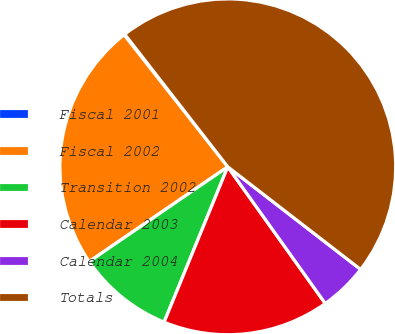Convert chart to OTSL. <chart><loc_0><loc_0><loc_500><loc_500><pie_chart><fcel>Fiscal 2001<fcel>Fiscal 2002<fcel>Transition 2002<fcel>Calendar 2003<fcel>Calendar 2004<fcel>Totals<nl><fcel>0.08%<fcel>23.95%<fcel>9.26%<fcel>16.05%<fcel>4.67%<fcel>45.98%<nl></chart> 